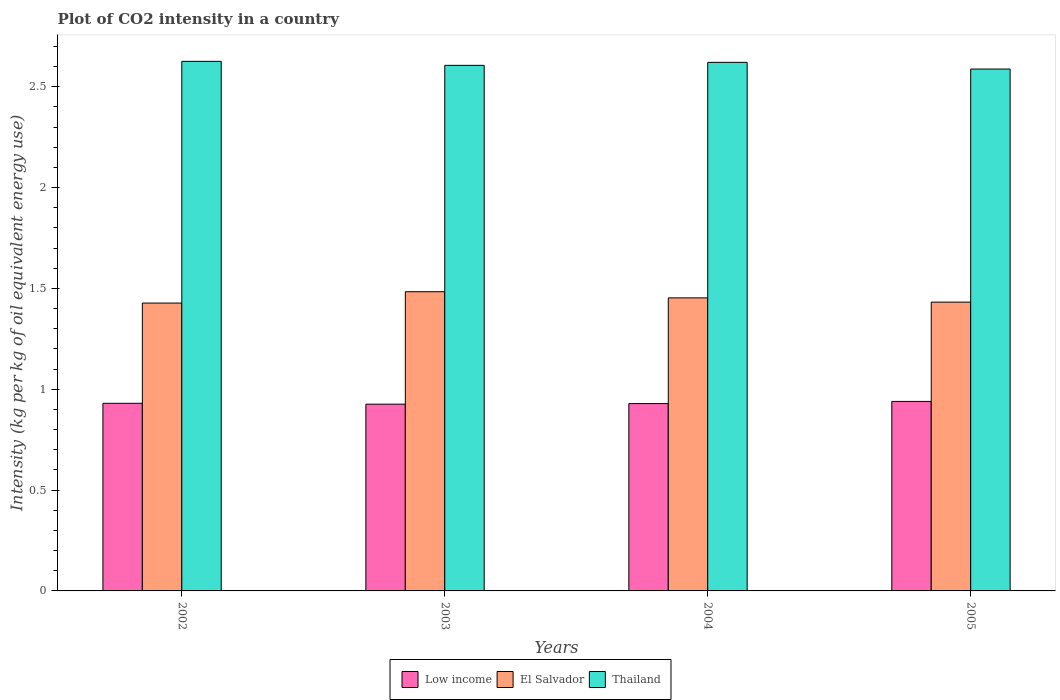How many different coloured bars are there?
Keep it short and to the point. 3. How many groups of bars are there?
Your response must be concise. 4. Are the number of bars on each tick of the X-axis equal?
Provide a short and direct response. Yes. How many bars are there on the 2nd tick from the right?
Your response must be concise. 3. What is the label of the 3rd group of bars from the left?
Your answer should be very brief. 2004. What is the CO2 intensity in in El Salvador in 2002?
Ensure brevity in your answer.  1.43. Across all years, what is the maximum CO2 intensity in in Low income?
Ensure brevity in your answer.  0.94. Across all years, what is the minimum CO2 intensity in in Low income?
Offer a very short reply. 0.93. In which year was the CO2 intensity in in Low income minimum?
Offer a terse response. 2003. What is the total CO2 intensity in in Low income in the graph?
Make the answer very short. 3.72. What is the difference between the CO2 intensity in in Thailand in 2002 and that in 2004?
Offer a terse response. 0. What is the difference between the CO2 intensity in in El Salvador in 2003 and the CO2 intensity in in Thailand in 2005?
Your answer should be compact. -1.1. What is the average CO2 intensity in in El Salvador per year?
Offer a terse response. 1.45. In the year 2003, what is the difference between the CO2 intensity in in El Salvador and CO2 intensity in in Low income?
Give a very brief answer. 0.56. In how many years, is the CO2 intensity in in Low income greater than 1.9 kg?
Keep it short and to the point. 0. What is the ratio of the CO2 intensity in in Thailand in 2002 to that in 2005?
Make the answer very short. 1.01. Is the difference between the CO2 intensity in in El Salvador in 2003 and 2004 greater than the difference between the CO2 intensity in in Low income in 2003 and 2004?
Give a very brief answer. Yes. What is the difference between the highest and the second highest CO2 intensity in in Thailand?
Ensure brevity in your answer.  0. What is the difference between the highest and the lowest CO2 intensity in in Thailand?
Your answer should be compact. 0.04. In how many years, is the CO2 intensity in in Thailand greater than the average CO2 intensity in in Thailand taken over all years?
Make the answer very short. 2. What does the 2nd bar from the left in 2004 represents?
Make the answer very short. El Salvador. What does the 2nd bar from the right in 2005 represents?
Provide a succinct answer. El Salvador. How many bars are there?
Ensure brevity in your answer.  12. Does the graph contain grids?
Your response must be concise. No. How many legend labels are there?
Offer a very short reply. 3. How are the legend labels stacked?
Give a very brief answer. Horizontal. What is the title of the graph?
Keep it short and to the point. Plot of CO2 intensity in a country. What is the label or title of the X-axis?
Make the answer very short. Years. What is the label or title of the Y-axis?
Provide a short and direct response. Intensity (kg per kg of oil equivalent energy use). What is the Intensity (kg per kg of oil equivalent energy use) of Low income in 2002?
Ensure brevity in your answer.  0.93. What is the Intensity (kg per kg of oil equivalent energy use) in El Salvador in 2002?
Make the answer very short. 1.43. What is the Intensity (kg per kg of oil equivalent energy use) in Thailand in 2002?
Your response must be concise. 2.63. What is the Intensity (kg per kg of oil equivalent energy use) of Low income in 2003?
Your answer should be very brief. 0.93. What is the Intensity (kg per kg of oil equivalent energy use) in El Salvador in 2003?
Provide a short and direct response. 1.48. What is the Intensity (kg per kg of oil equivalent energy use) in Thailand in 2003?
Your answer should be compact. 2.61. What is the Intensity (kg per kg of oil equivalent energy use) in Low income in 2004?
Keep it short and to the point. 0.93. What is the Intensity (kg per kg of oil equivalent energy use) in El Salvador in 2004?
Give a very brief answer. 1.45. What is the Intensity (kg per kg of oil equivalent energy use) of Thailand in 2004?
Offer a terse response. 2.62. What is the Intensity (kg per kg of oil equivalent energy use) in Low income in 2005?
Ensure brevity in your answer.  0.94. What is the Intensity (kg per kg of oil equivalent energy use) in El Salvador in 2005?
Keep it short and to the point. 1.43. What is the Intensity (kg per kg of oil equivalent energy use) of Thailand in 2005?
Provide a short and direct response. 2.59. Across all years, what is the maximum Intensity (kg per kg of oil equivalent energy use) of Low income?
Offer a very short reply. 0.94. Across all years, what is the maximum Intensity (kg per kg of oil equivalent energy use) of El Salvador?
Make the answer very short. 1.48. Across all years, what is the maximum Intensity (kg per kg of oil equivalent energy use) in Thailand?
Provide a succinct answer. 2.63. Across all years, what is the minimum Intensity (kg per kg of oil equivalent energy use) in Low income?
Offer a terse response. 0.93. Across all years, what is the minimum Intensity (kg per kg of oil equivalent energy use) in El Salvador?
Keep it short and to the point. 1.43. Across all years, what is the minimum Intensity (kg per kg of oil equivalent energy use) in Thailand?
Provide a succinct answer. 2.59. What is the total Intensity (kg per kg of oil equivalent energy use) in Low income in the graph?
Your answer should be very brief. 3.72. What is the total Intensity (kg per kg of oil equivalent energy use) of El Salvador in the graph?
Ensure brevity in your answer.  5.8. What is the total Intensity (kg per kg of oil equivalent energy use) in Thailand in the graph?
Your answer should be compact. 10.44. What is the difference between the Intensity (kg per kg of oil equivalent energy use) in Low income in 2002 and that in 2003?
Your answer should be very brief. 0. What is the difference between the Intensity (kg per kg of oil equivalent energy use) in El Salvador in 2002 and that in 2003?
Provide a short and direct response. -0.06. What is the difference between the Intensity (kg per kg of oil equivalent energy use) in Thailand in 2002 and that in 2003?
Offer a very short reply. 0.02. What is the difference between the Intensity (kg per kg of oil equivalent energy use) of Low income in 2002 and that in 2004?
Keep it short and to the point. 0. What is the difference between the Intensity (kg per kg of oil equivalent energy use) in El Salvador in 2002 and that in 2004?
Provide a short and direct response. -0.03. What is the difference between the Intensity (kg per kg of oil equivalent energy use) in Thailand in 2002 and that in 2004?
Your answer should be compact. 0.01. What is the difference between the Intensity (kg per kg of oil equivalent energy use) in Low income in 2002 and that in 2005?
Offer a terse response. -0.01. What is the difference between the Intensity (kg per kg of oil equivalent energy use) of El Salvador in 2002 and that in 2005?
Provide a succinct answer. -0. What is the difference between the Intensity (kg per kg of oil equivalent energy use) in Thailand in 2002 and that in 2005?
Your response must be concise. 0.04. What is the difference between the Intensity (kg per kg of oil equivalent energy use) of Low income in 2003 and that in 2004?
Your answer should be very brief. -0. What is the difference between the Intensity (kg per kg of oil equivalent energy use) of El Salvador in 2003 and that in 2004?
Provide a short and direct response. 0.03. What is the difference between the Intensity (kg per kg of oil equivalent energy use) in Thailand in 2003 and that in 2004?
Ensure brevity in your answer.  -0.01. What is the difference between the Intensity (kg per kg of oil equivalent energy use) of Low income in 2003 and that in 2005?
Your response must be concise. -0.01. What is the difference between the Intensity (kg per kg of oil equivalent energy use) in El Salvador in 2003 and that in 2005?
Offer a very short reply. 0.05. What is the difference between the Intensity (kg per kg of oil equivalent energy use) of Thailand in 2003 and that in 2005?
Offer a terse response. 0.02. What is the difference between the Intensity (kg per kg of oil equivalent energy use) in Low income in 2004 and that in 2005?
Make the answer very short. -0.01. What is the difference between the Intensity (kg per kg of oil equivalent energy use) in El Salvador in 2004 and that in 2005?
Offer a terse response. 0.02. What is the difference between the Intensity (kg per kg of oil equivalent energy use) of Thailand in 2004 and that in 2005?
Provide a short and direct response. 0.03. What is the difference between the Intensity (kg per kg of oil equivalent energy use) of Low income in 2002 and the Intensity (kg per kg of oil equivalent energy use) of El Salvador in 2003?
Your response must be concise. -0.55. What is the difference between the Intensity (kg per kg of oil equivalent energy use) of Low income in 2002 and the Intensity (kg per kg of oil equivalent energy use) of Thailand in 2003?
Offer a very short reply. -1.68. What is the difference between the Intensity (kg per kg of oil equivalent energy use) of El Salvador in 2002 and the Intensity (kg per kg of oil equivalent energy use) of Thailand in 2003?
Keep it short and to the point. -1.18. What is the difference between the Intensity (kg per kg of oil equivalent energy use) of Low income in 2002 and the Intensity (kg per kg of oil equivalent energy use) of El Salvador in 2004?
Keep it short and to the point. -0.52. What is the difference between the Intensity (kg per kg of oil equivalent energy use) in Low income in 2002 and the Intensity (kg per kg of oil equivalent energy use) in Thailand in 2004?
Provide a succinct answer. -1.69. What is the difference between the Intensity (kg per kg of oil equivalent energy use) in El Salvador in 2002 and the Intensity (kg per kg of oil equivalent energy use) in Thailand in 2004?
Keep it short and to the point. -1.19. What is the difference between the Intensity (kg per kg of oil equivalent energy use) of Low income in 2002 and the Intensity (kg per kg of oil equivalent energy use) of El Salvador in 2005?
Provide a short and direct response. -0.5. What is the difference between the Intensity (kg per kg of oil equivalent energy use) in Low income in 2002 and the Intensity (kg per kg of oil equivalent energy use) in Thailand in 2005?
Your response must be concise. -1.66. What is the difference between the Intensity (kg per kg of oil equivalent energy use) of El Salvador in 2002 and the Intensity (kg per kg of oil equivalent energy use) of Thailand in 2005?
Ensure brevity in your answer.  -1.16. What is the difference between the Intensity (kg per kg of oil equivalent energy use) of Low income in 2003 and the Intensity (kg per kg of oil equivalent energy use) of El Salvador in 2004?
Keep it short and to the point. -0.53. What is the difference between the Intensity (kg per kg of oil equivalent energy use) of Low income in 2003 and the Intensity (kg per kg of oil equivalent energy use) of Thailand in 2004?
Ensure brevity in your answer.  -1.69. What is the difference between the Intensity (kg per kg of oil equivalent energy use) in El Salvador in 2003 and the Intensity (kg per kg of oil equivalent energy use) in Thailand in 2004?
Make the answer very short. -1.14. What is the difference between the Intensity (kg per kg of oil equivalent energy use) of Low income in 2003 and the Intensity (kg per kg of oil equivalent energy use) of El Salvador in 2005?
Your response must be concise. -0.51. What is the difference between the Intensity (kg per kg of oil equivalent energy use) of Low income in 2003 and the Intensity (kg per kg of oil equivalent energy use) of Thailand in 2005?
Give a very brief answer. -1.66. What is the difference between the Intensity (kg per kg of oil equivalent energy use) in El Salvador in 2003 and the Intensity (kg per kg of oil equivalent energy use) in Thailand in 2005?
Your response must be concise. -1.1. What is the difference between the Intensity (kg per kg of oil equivalent energy use) of Low income in 2004 and the Intensity (kg per kg of oil equivalent energy use) of El Salvador in 2005?
Your answer should be compact. -0.5. What is the difference between the Intensity (kg per kg of oil equivalent energy use) in Low income in 2004 and the Intensity (kg per kg of oil equivalent energy use) in Thailand in 2005?
Your answer should be very brief. -1.66. What is the difference between the Intensity (kg per kg of oil equivalent energy use) of El Salvador in 2004 and the Intensity (kg per kg of oil equivalent energy use) of Thailand in 2005?
Ensure brevity in your answer.  -1.13. What is the average Intensity (kg per kg of oil equivalent energy use) of Low income per year?
Your answer should be compact. 0.93. What is the average Intensity (kg per kg of oil equivalent energy use) of El Salvador per year?
Provide a short and direct response. 1.45. What is the average Intensity (kg per kg of oil equivalent energy use) in Thailand per year?
Your answer should be compact. 2.61. In the year 2002, what is the difference between the Intensity (kg per kg of oil equivalent energy use) in Low income and Intensity (kg per kg of oil equivalent energy use) in El Salvador?
Your response must be concise. -0.5. In the year 2002, what is the difference between the Intensity (kg per kg of oil equivalent energy use) of Low income and Intensity (kg per kg of oil equivalent energy use) of Thailand?
Provide a succinct answer. -1.7. In the year 2002, what is the difference between the Intensity (kg per kg of oil equivalent energy use) in El Salvador and Intensity (kg per kg of oil equivalent energy use) in Thailand?
Offer a very short reply. -1.2. In the year 2003, what is the difference between the Intensity (kg per kg of oil equivalent energy use) of Low income and Intensity (kg per kg of oil equivalent energy use) of El Salvador?
Offer a very short reply. -0.56. In the year 2003, what is the difference between the Intensity (kg per kg of oil equivalent energy use) of Low income and Intensity (kg per kg of oil equivalent energy use) of Thailand?
Provide a succinct answer. -1.68. In the year 2003, what is the difference between the Intensity (kg per kg of oil equivalent energy use) of El Salvador and Intensity (kg per kg of oil equivalent energy use) of Thailand?
Give a very brief answer. -1.12. In the year 2004, what is the difference between the Intensity (kg per kg of oil equivalent energy use) in Low income and Intensity (kg per kg of oil equivalent energy use) in El Salvador?
Your answer should be compact. -0.52. In the year 2004, what is the difference between the Intensity (kg per kg of oil equivalent energy use) of Low income and Intensity (kg per kg of oil equivalent energy use) of Thailand?
Give a very brief answer. -1.69. In the year 2004, what is the difference between the Intensity (kg per kg of oil equivalent energy use) of El Salvador and Intensity (kg per kg of oil equivalent energy use) of Thailand?
Offer a terse response. -1.17. In the year 2005, what is the difference between the Intensity (kg per kg of oil equivalent energy use) in Low income and Intensity (kg per kg of oil equivalent energy use) in El Salvador?
Your answer should be very brief. -0.49. In the year 2005, what is the difference between the Intensity (kg per kg of oil equivalent energy use) in Low income and Intensity (kg per kg of oil equivalent energy use) in Thailand?
Provide a succinct answer. -1.65. In the year 2005, what is the difference between the Intensity (kg per kg of oil equivalent energy use) of El Salvador and Intensity (kg per kg of oil equivalent energy use) of Thailand?
Provide a short and direct response. -1.16. What is the ratio of the Intensity (kg per kg of oil equivalent energy use) in Low income in 2002 to that in 2003?
Make the answer very short. 1. What is the ratio of the Intensity (kg per kg of oil equivalent energy use) in El Salvador in 2002 to that in 2003?
Your answer should be compact. 0.96. What is the ratio of the Intensity (kg per kg of oil equivalent energy use) in Thailand in 2002 to that in 2003?
Your answer should be compact. 1.01. What is the ratio of the Intensity (kg per kg of oil equivalent energy use) in El Salvador in 2002 to that in 2004?
Your answer should be compact. 0.98. What is the ratio of the Intensity (kg per kg of oil equivalent energy use) in Thailand in 2002 to that in 2004?
Provide a short and direct response. 1. What is the ratio of the Intensity (kg per kg of oil equivalent energy use) of Low income in 2002 to that in 2005?
Offer a very short reply. 0.99. What is the ratio of the Intensity (kg per kg of oil equivalent energy use) in El Salvador in 2002 to that in 2005?
Your answer should be compact. 1. What is the ratio of the Intensity (kg per kg of oil equivalent energy use) in Thailand in 2002 to that in 2005?
Offer a very short reply. 1.01. What is the ratio of the Intensity (kg per kg of oil equivalent energy use) of Low income in 2003 to that in 2004?
Your response must be concise. 1. What is the ratio of the Intensity (kg per kg of oil equivalent energy use) of El Salvador in 2003 to that in 2004?
Ensure brevity in your answer.  1.02. What is the ratio of the Intensity (kg per kg of oil equivalent energy use) of Thailand in 2003 to that in 2004?
Your answer should be compact. 0.99. What is the ratio of the Intensity (kg per kg of oil equivalent energy use) of Low income in 2003 to that in 2005?
Offer a very short reply. 0.99. What is the ratio of the Intensity (kg per kg of oil equivalent energy use) of El Salvador in 2003 to that in 2005?
Offer a very short reply. 1.04. What is the ratio of the Intensity (kg per kg of oil equivalent energy use) in Thailand in 2003 to that in 2005?
Offer a terse response. 1.01. What is the ratio of the Intensity (kg per kg of oil equivalent energy use) in Low income in 2004 to that in 2005?
Provide a succinct answer. 0.99. What is the ratio of the Intensity (kg per kg of oil equivalent energy use) in El Salvador in 2004 to that in 2005?
Your response must be concise. 1.01. What is the ratio of the Intensity (kg per kg of oil equivalent energy use) in Thailand in 2004 to that in 2005?
Keep it short and to the point. 1.01. What is the difference between the highest and the second highest Intensity (kg per kg of oil equivalent energy use) of Low income?
Your answer should be very brief. 0.01. What is the difference between the highest and the second highest Intensity (kg per kg of oil equivalent energy use) of El Salvador?
Provide a short and direct response. 0.03. What is the difference between the highest and the second highest Intensity (kg per kg of oil equivalent energy use) of Thailand?
Offer a terse response. 0.01. What is the difference between the highest and the lowest Intensity (kg per kg of oil equivalent energy use) in Low income?
Provide a succinct answer. 0.01. What is the difference between the highest and the lowest Intensity (kg per kg of oil equivalent energy use) of El Salvador?
Provide a succinct answer. 0.06. What is the difference between the highest and the lowest Intensity (kg per kg of oil equivalent energy use) in Thailand?
Your answer should be compact. 0.04. 